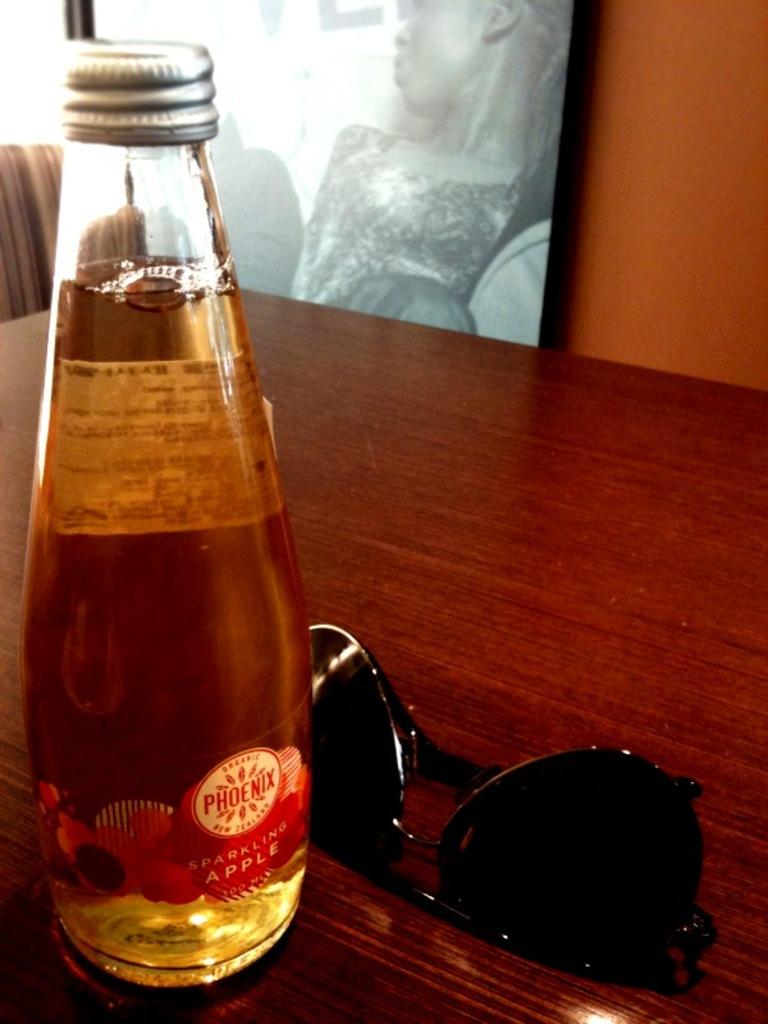What fruit is cited on the bottle?
Keep it short and to the point. Apple. What city does it say in the circle?
Make the answer very short. Phoenix. 